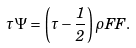<formula> <loc_0><loc_0><loc_500><loc_500>\tau \Psi = \left ( \tau - \frac { 1 } { 2 } \right ) \rho F F .</formula> 